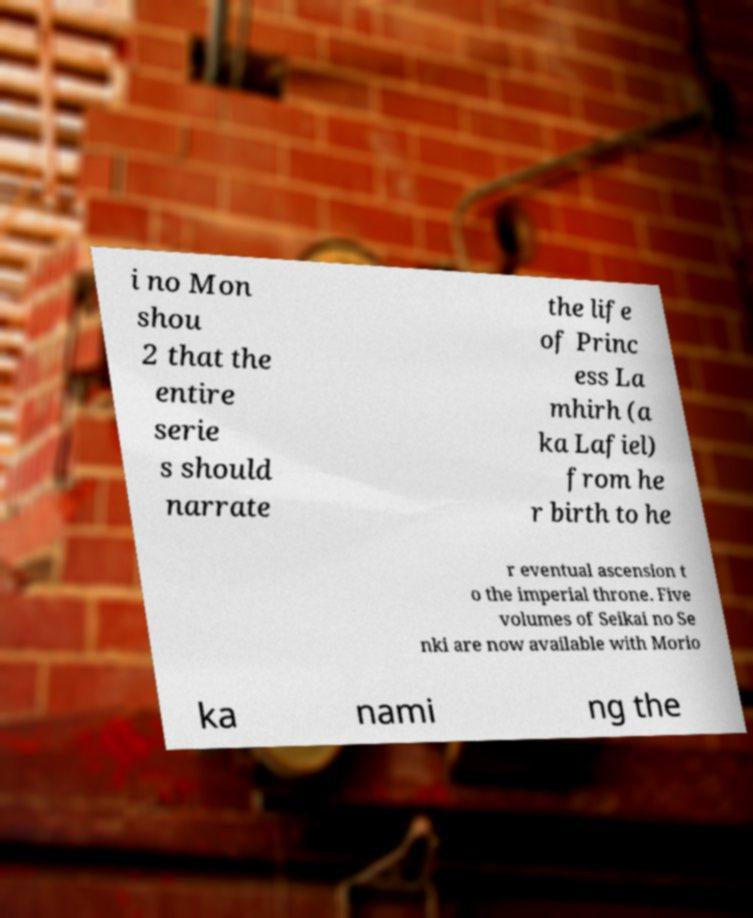Please identify and transcribe the text found in this image. i no Mon shou 2 that the entire serie s should narrate the life of Princ ess La mhirh (a ka Lafiel) from he r birth to he r eventual ascension t o the imperial throne. Five volumes of Seikai no Se nki are now available with Morio ka nami ng the 